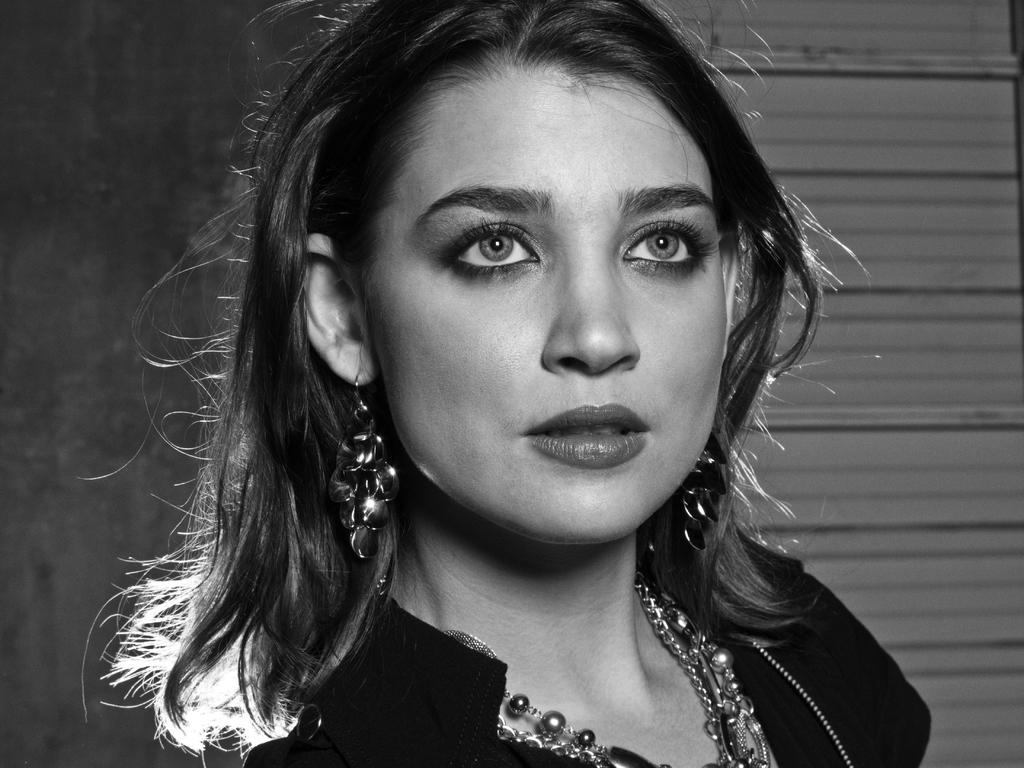What is the color scheme of the image? The image is black and white. Can you describe the main subject in the image? There is a person in the image. What can be seen behind the person in the image? There is the background in the image. What type of art is the scarecrow creating in the image? There is no scarecrow present in the image, and therefore no art can be observed. 